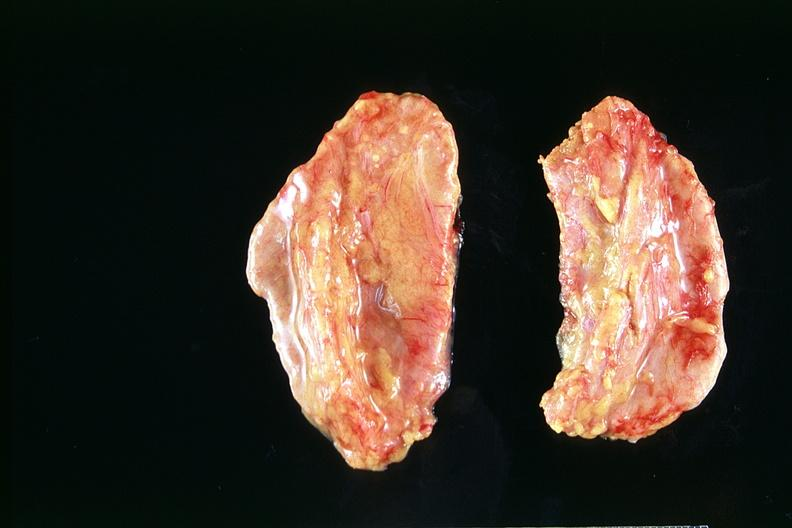what does this image show?
Answer the question using a single word or phrase. Adrenals 